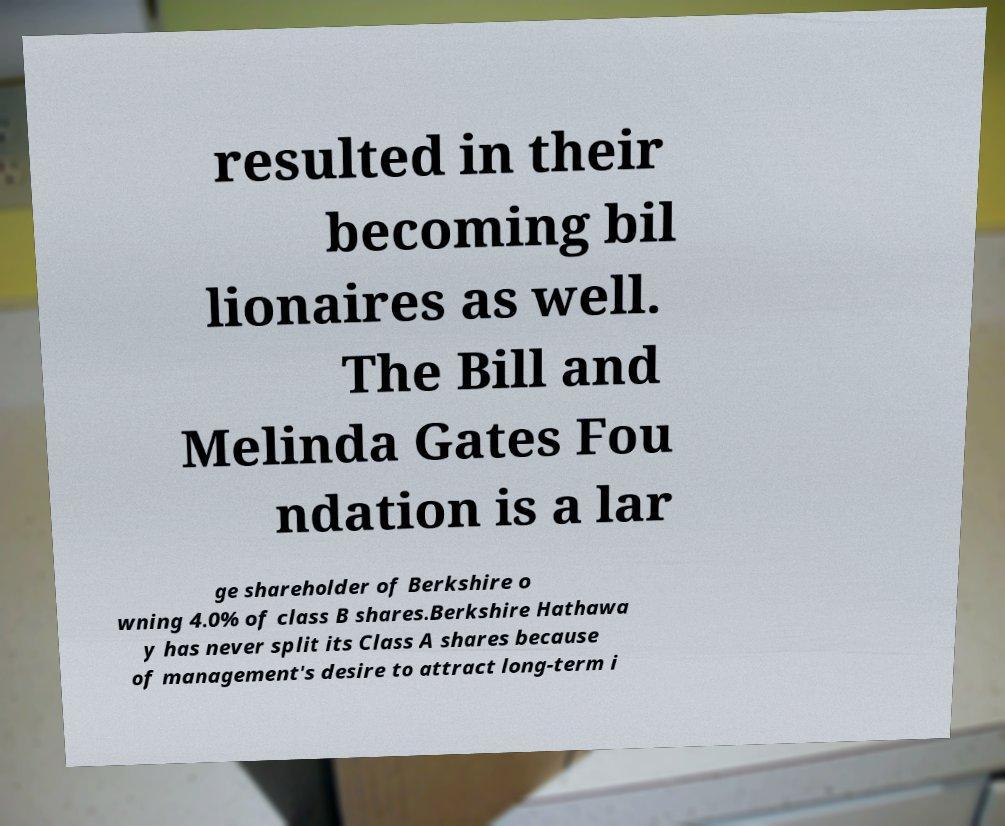Could you assist in decoding the text presented in this image and type it out clearly? resulted in their becoming bil lionaires as well. The Bill and Melinda Gates Fou ndation is a lar ge shareholder of Berkshire o wning 4.0% of class B shares.Berkshire Hathawa y has never split its Class A shares because of management's desire to attract long-term i 